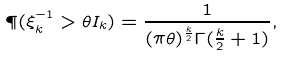Convert formula to latex. <formula><loc_0><loc_0><loc_500><loc_500>\P ( \xi _ { k } ^ { - 1 } > \theta I _ { k } ) = \frac { 1 } { ( \pi \theta ) ^ { \frac { k } { 2 } } \Gamma ( \frac { k } { 2 } + 1 ) } ,</formula> 